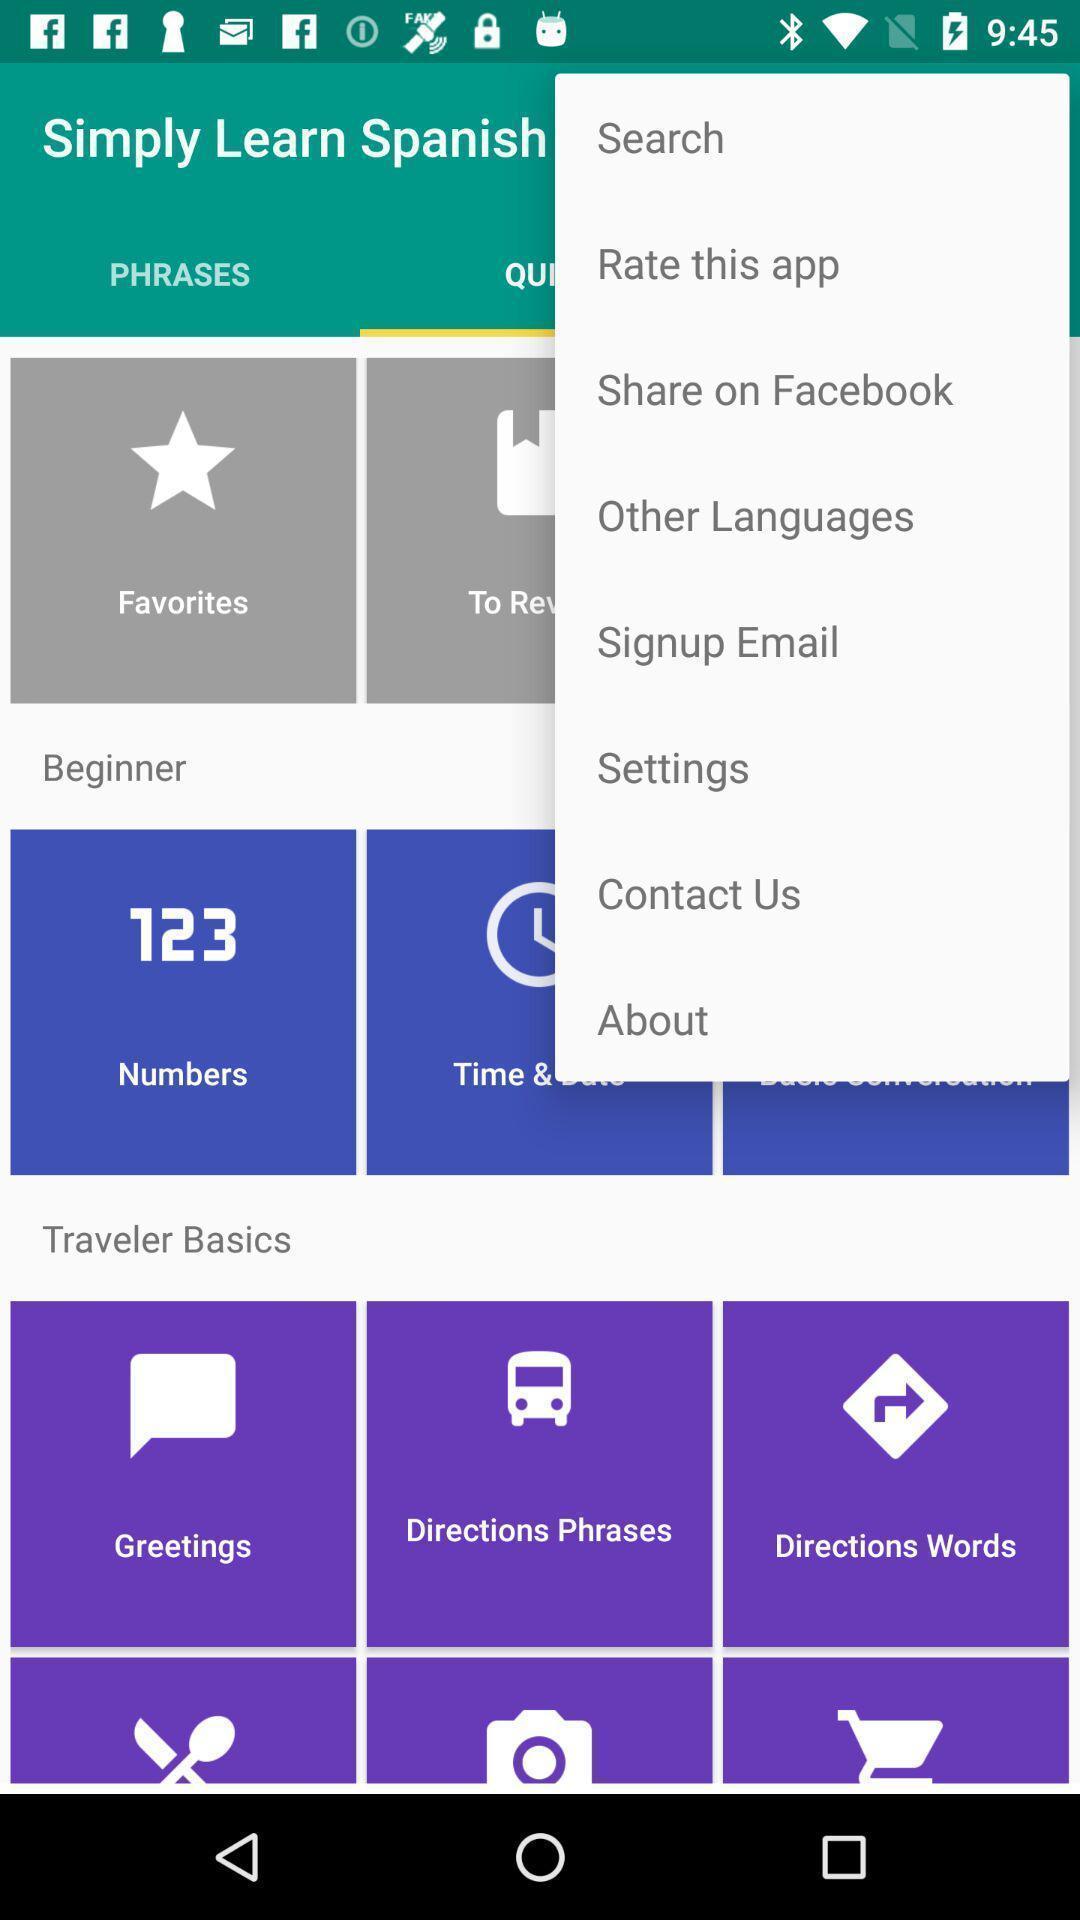What details can you identify in this image? Page shows multiple options in language learning application. 